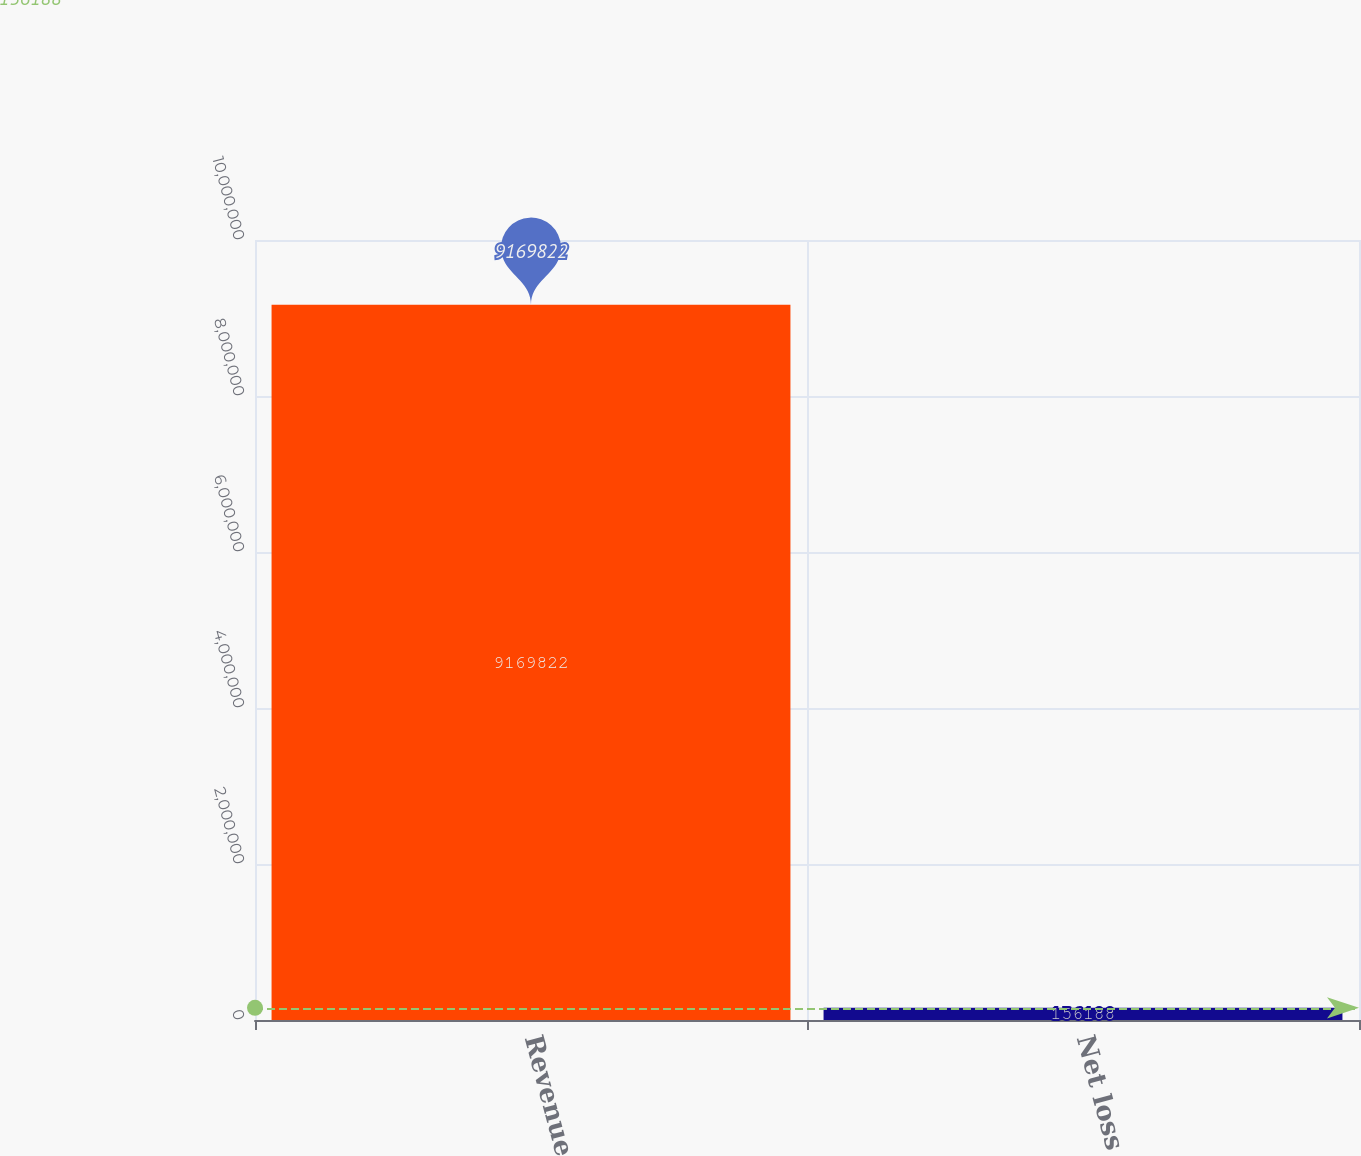<chart> <loc_0><loc_0><loc_500><loc_500><bar_chart><fcel>Revenue<fcel>Net loss<nl><fcel>9.16982e+06<fcel>156188<nl></chart> 